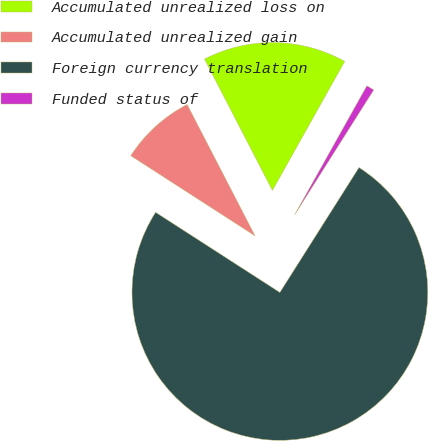Convert chart. <chart><loc_0><loc_0><loc_500><loc_500><pie_chart><fcel>Accumulated unrealized loss on<fcel>Accumulated unrealized gain<fcel>Foreign currency translation<fcel>Funded status of<nl><fcel>15.72%<fcel>8.29%<fcel>75.13%<fcel>0.86%<nl></chart> 